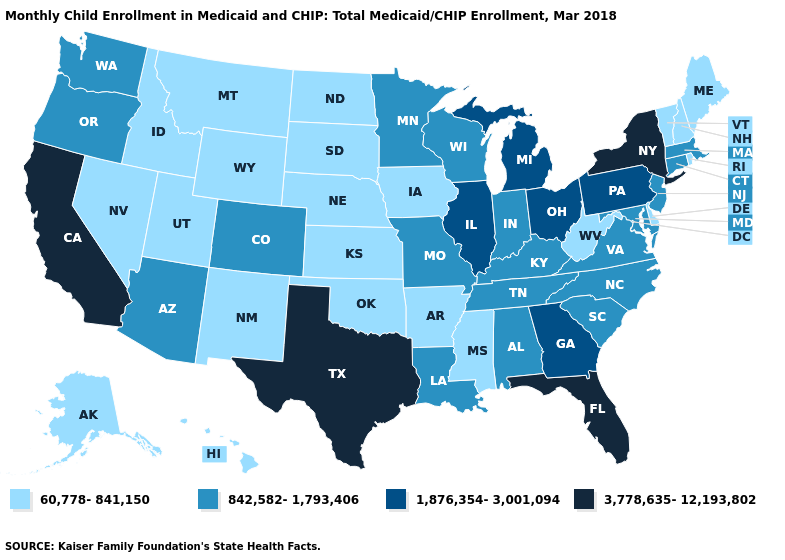Name the states that have a value in the range 3,778,635-12,193,802?
Write a very short answer. California, Florida, New York, Texas. Among the states that border Colorado , does Oklahoma have the lowest value?
Keep it brief. Yes. Does North Carolina have a lower value than Georgia?
Answer briefly. Yes. Does Nebraska have the highest value in the MidWest?
Concise answer only. No. What is the value of New York?
Be succinct. 3,778,635-12,193,802. Does California have the highest value in the USA?
Give a very brief answer. Yes. Does the first symbol in the legend represent the smallest category?
Short answer required. Yes. Does New York have the lowest value in the Northeast?
Quick response, please. No. Name the states that have a value in the range 3,778,635-12,193,802?
Short answer required. California, Florida, New York, Texas. Which states have the lowest value in the West?
Write a very short answer. Alaska, Hawaii, Idaho, Montana, Nevada, New Mexico, Utah, Wyoming. Which states have the lowest value in the Northeast?
Answer briefly. Maine, New Hampshire, Rhode Island, Vermont. Name the states that have a value in the range 3,778,635-12,193,802?
Quick response, please. California, Florida, New York, Texas. Name the states that have a value in the range 60,778-841,150?
Be succinct. Alaska, Arkansas, Delaware, Hawaii, Idaho, Iowa, Kansas, Maine, Mississippi, Montana, Nebraska, Nevada, New Hampshire, New Mexico, North Dakota, Oklahoma, Rhode Island, South Dakota, Utah, Vermont, West Virginia, Wyoming. Name the states that have a value in the range 842,582-1,793,406?
Write a very short answer. Alabama, Arizona, Colorado, Connecticut, Indiana, Kentucky, Louisiana, Maryland, Massachusetts, Minnesota, Missouri, New Jersey, North Carolina, Oregon, South Carolina, Tennessee, Virginia, Washington, Wisconsin. Which states have the lowest value in the USA?
Keep it brief. Alaska, Arkansas, Delaware, Hawaii, Idaho, Iowa, Kansas, Maine, Mississippi, Montana, Nebraska, Nevada, New Hampshire, New Mexico, North Dakota, Oklahoma, Rhode Island, South Dakota, Utah, Vermont, West Virginia, Wyoming. 